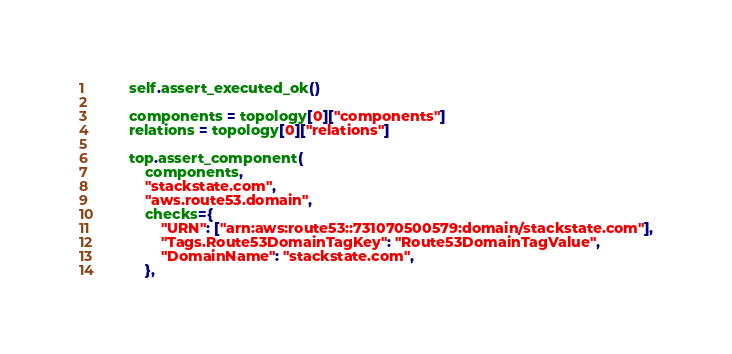<code> <loc_0><loc_0><loc_500><loc_500><_Python_>        self.assert_executed_ok()

        components = topology[0]["components"]
        relations = topology[0]["relations"]

        top.assert_component(
            components,
            "stackstate.com",
            "aws.route53.domain",
            checks={
                "URN": ["arn:aws:route53::731070500579:domain/stackstate.com"],
                "Tags.Route53DomainTagKey": "Route53DomainTagValue",
                "DomainName": "stackstate.com",
            },</code> 